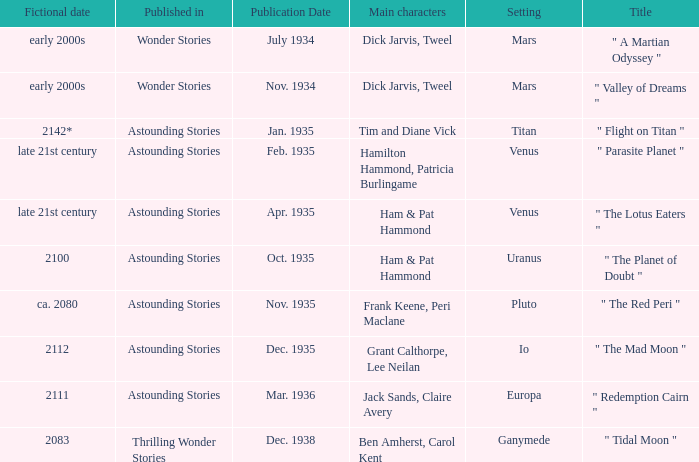Name what was published in july 1934 with a setting of mars Wonder Stories. 